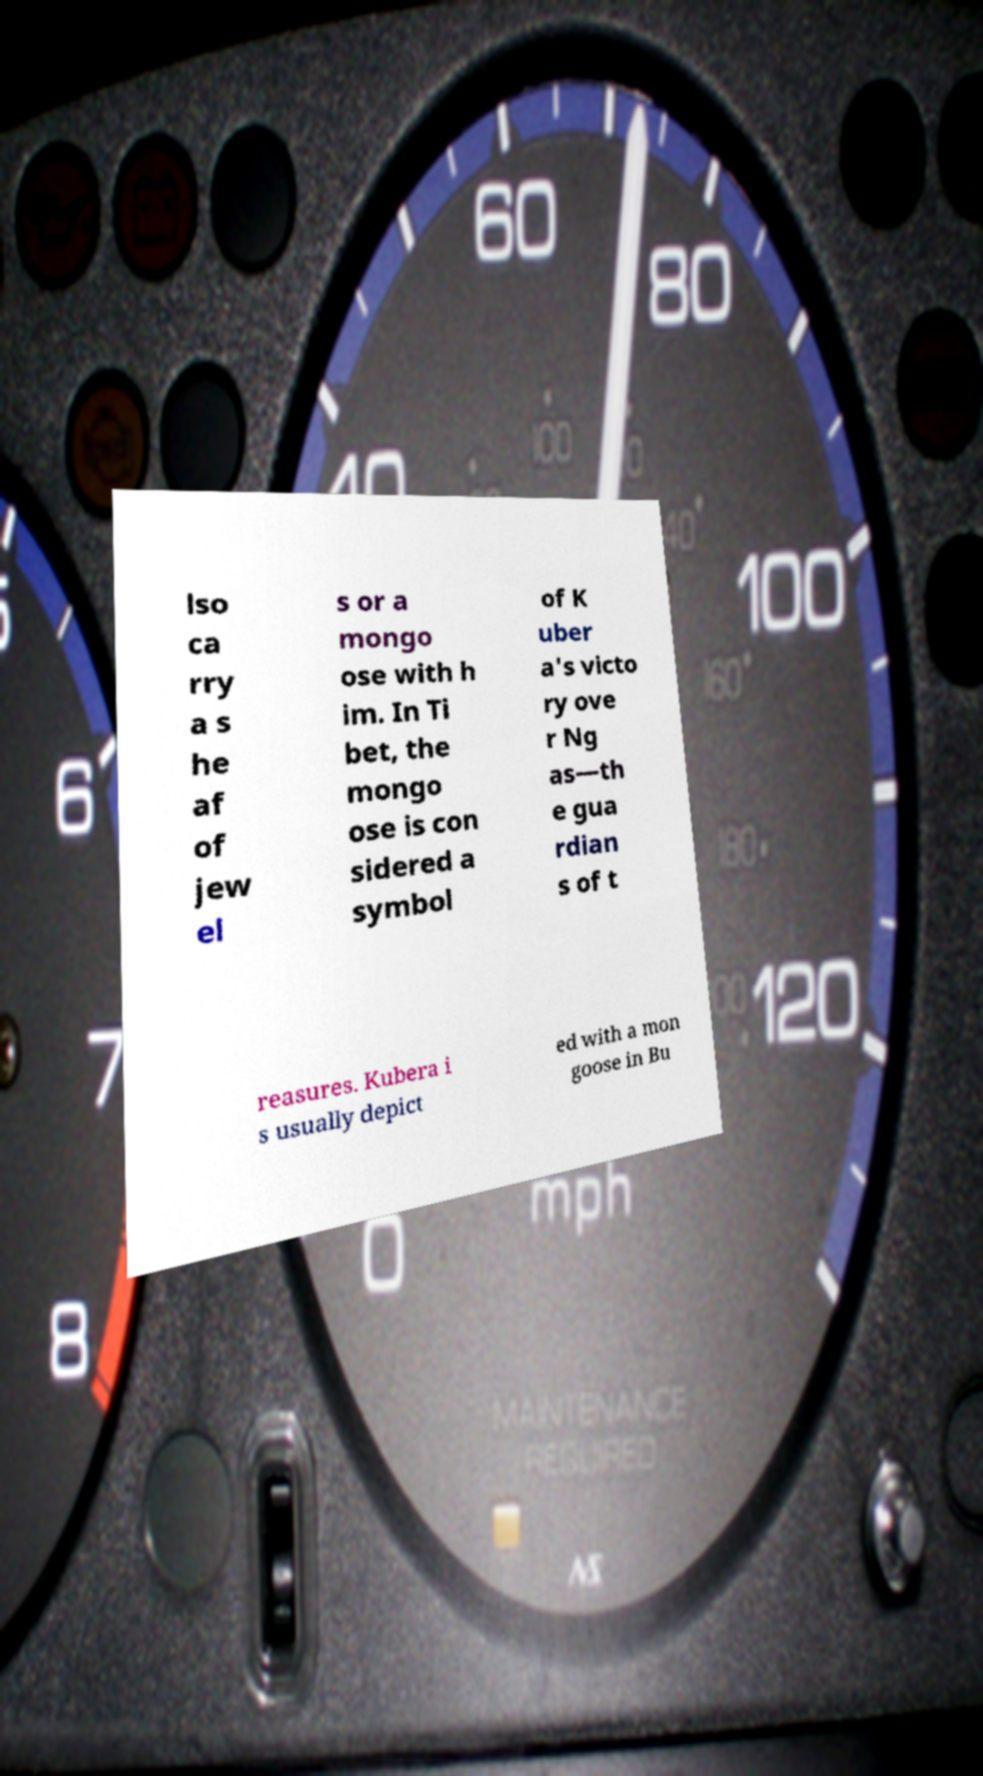I need the written content from this picture converted into text. Can you do that? lso ca rry a s he af of jew el s or a mongo ose with h im. In Ti bet, the mongo ose is con sidered a symbol of K uber a's victo ry ove r Ng as—th e gua rdian s of t reasures. Kubera i s usually depict ed with a mon goose in Bu 